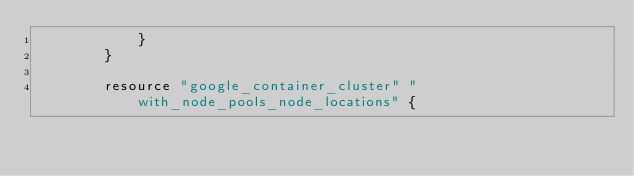<code> <loc_0><loc_0><loc_500><loc_500><_Go_>			}
		}

		resource "google_container_cluster" "with_node_pools_node_locations" {</code> 